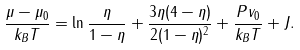<formula> <loc_0><loc_0><loc_500><loc_500>\frac { \mu - \mu _ { 0 } } { k _ { B } T } = \ln \frac { \eta } { 1 - \eta } + \frac { 3 \eta ( 4 - \eta ) } { 2 ( 1 - \eta ) ^ { 2 } } + \frac { P v _ { 0 } } { k _ { B } T } + J .</formula> 